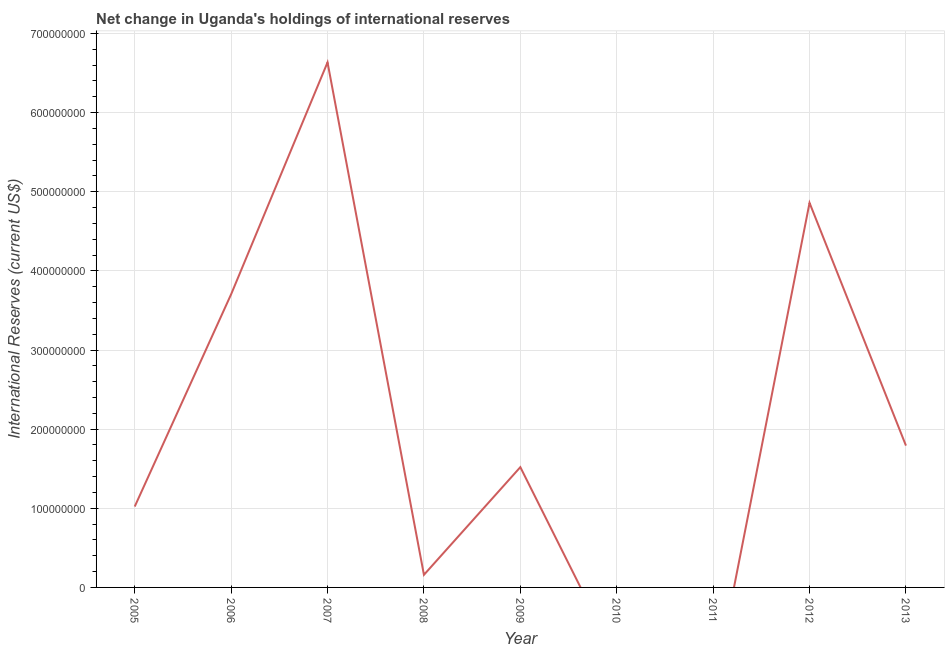What is the reserves and related items in 2012?
Ensure brevity in your answer.  4.86e+08. Across all years, what is the maximum reserves and related items?
Keep it short and to the point. 6.64e+08. Across all years, what is the minimum reserves and related items?
Offer a terse response. 0. What is the sum of the reserves and related items?
Give a very brief answer. 1.97e+09. What is the difference between the reserves and related items in 2012 and 2013?
Provide a short and direct response. 3.07e+08. What is the average reserves and related items per year?
Offer a terse response. 2.19e+08. What is the median reserves and related items?
Ensure brevity in your answer.  1.52e+08. In how many years, is the reserves and related items greater than 280000000 US$?
Your answer should be compact. 3. What is the ratio of the reserves and related items in 2012 to that in 2013?
Your response must be concise. 2.71. Is the reserves and related items in 2005 less than that in 2007?
Offer a very short reply. Yes. What is the difference between the highest and the second highest reserves and related items?
Your answer should be very brief. 1.78e+08. Is the sum of the reserves and related items in 2005 and 2007 greater than the maximum reserves and related items across all years?
Provide a short and direct response. Yes. What is the difference between the highest and the lowest reserves and related items?
Offer a very short reply. 6.64e+08. In how many years, is the reserves and related items greater than the average reserves and related items taken over all years?
Provide a short and direct response. 3. How many lines are there?
Your answer should be compact. 1. Are the values on the major ticks of Y-axis written in scientific E-notation?
Keep it short and to the point. No. Does the graph contain any zero values?
Ensure brevity in your answer.  Yes. What is the title of the graph?
Your answer should be very brief. Net change in Uganda's holdings of international reserves. What is the label or title of the X-axis?
Offer a very short reply. Year. What is the label or title of the Y-axis?
Provide a succinct answer. International Reserves (current US$). What is the International Reserves (current US$) in 2005?
Offer a very short reply. 1.02e+08. What is the International Reserves (current US$) in 2006?
Your answer should be compact. 3.70e+08. What is the International Reserves (current US$) of 2007?
Keep it short and to the point. 6.64e+08. What is the International Reserves (current US$) of 2008?
Ensure brevity in your answer.  1.59e+07. What is the International Reserves (current US$) of 2009?
Give a very brief answer. 1.52e+08. What is the International Reserves (current US$) of 2012?
Keep it short and to the point. 4.86e+08. What is the International Reserves (current US$) in 2013?
Offer a very short reply. 1.79e+08. What is the difference between the International Reserves (current US$) in 2005 and 2006?
Your answer should be compact. -2.68e+08. What is the difference between the International Reserves (current US$) in 2005 and 2007?
Your answer should be compact. -5.61e+08. What is the difference between the International Reserves (current US$) in 2005 and 2008?
Give a very brief answer. 8.63e+07. What is the difference between the International Reserves (current US$) in 2005 and 2009?
Give a very brief answer. -4.98e+07. What is the difference between the International Reserves (current US$) in 2005 and 2012?
Provide a succinct answer. -3.84e+08. What is the difference between the International Reserves (current US$) in 2005 and 2013?
Provide a short and direct response. -7.70e+07. What is the difference between the International Reserves (current US$) in 2006 and 2007?
Provide a short and direct response. -2.93e+08. What is the difference between the International Reserves (current US$) in 2006 and 2008?
Offer a terse response. 3.55e+08. What is the difference between the International Reserves (current US$) in 2006 and 2009?
Provide a short and direct response. 2.19e+08. What is the difference between the International Reserves (current US$) in 2006 and 2012?
Your answer should be very brief. -1.16e+08. What is the difference between the International Reserves (current US$) in 2006 and 2013?
Provide a succinct answer. 1.91e+08. What is the difference between the International Reserves (current US$) in 2007 and 2008?
Your response must be concise. 6.48e+08. What is the difference between the International Reserves (current US$) in 2007 and 2009?
Give a very brief answer. 5.12e+08. What is the difference between the International Reserves (current US$) in 2007 and 2012?
Ensure brevity in your answer.  1.78e+08. What is the difference between the International Reserves (current US$) in 2007 and 2013?
Provide a short and direct response. 4.84e+08. What is the difference between the International Reserves (current US$) in 2008 and 2009?
Give a very brief answer. -1.36e+08. What is the difference between the International Reserves (current US$) in 2008 and 2012?
Provide a succinct answer. -4.70e+08. What is the difference between the International Reserves (current US$) in 2008 and 2013?
Ensure brevity in your answer.  -1.63e+08. What is the difference between the International Reserves (current US$) in 2009 and 2012?
Your answer should be compact. -3.34e+08. What is the difference between the International Reserves (current US$) in 2009 and 2013?
Make the answer very short. -2.72e+07. What is the difference between the International Reserves (current US$) in 2012 and 2013?
Give a very brief answer. 3.07e+08. What is the ratio of the International Reserves (current US$) in 2005 to that in 2006?
Your answer should be very brief. 0.28. What is the ratio of the International Reserves (current US$) in 2005 to that in 2007?
Make the answer very short. 0.15. What is the ratio of the International Reserves (current US$) in 2005 to that in 2008?
Your answer should be compact. 6.42. What is the ratio of the International Reserves (current US$) in 2005 to that in 2009?
Keep it short and to the point. 0.67. What is the ratio of the International Reserves (current US$) in 2005 to that in 2012?
Offer a very short reply. 0.21. What is the ratio of the International Reserves (current US$) in 2005 to that in 2013?
Make the answer very short. 0.57. What is the ratio of the International Reserves (current US$) in 2006 to that in 2007?
Your answer should be very brief. 0.56. What is the ratio of the International Reserves (current US$) in 2006 to that in 2008?
Your response must be concise. 23.27. What is the ratio of the International Reserves (current US$) in 2006 to that in 2009?
Your response must be concise. 2.44. What is the ratio of the International Reserves (current US$) in 2006 to that in 2012?
Your response must be concise. 0.76. What is the ratio of the International Reserves (current US$) in 2006 to that in 2013?
Your answer should be very brief. 2.07. What is the ratio of the International Reserves (current US$) in 2007 to that in 2008?
Offer a very short reply. 41.68. What is the ratio of the International Reserves (current US$) in 2007 to that in 2009?
Provide a short and direct response. 4.37. What is the ratio of the International Reserves (current US$) in 2007 to that in 2012?
Your answer should be very brief. 1.36. What is the ratio of the International Reserves (current US$) in 2007 to that in 2013?
Offer a terse response. 3.7. What is the ratio of the International Reserves (current US$) in 2008 to that in 2009?
Your answer should be very brief. 0.1. What is the ratio of the International Reserves (current US$) in 2008 to that in 2012?
Keep it short and to the point. 0.03. What is the ratio of the International Reserves (current US$) in 2008 to that in 2013?
Provide a succinct answer. 0.09. What is the ratio of the International Reserves (current US$) in 2009 to that in 2012?
Your response must be concise. 0.31. What is the ratio of the International Reserves (current US$) in 2009 to that in 2013?
Provide a short and direct response. 0.85. What is the ratio of the International Reserves (current US$) in 2012 to that in 2013?
Offer a terse response. 2.71. 